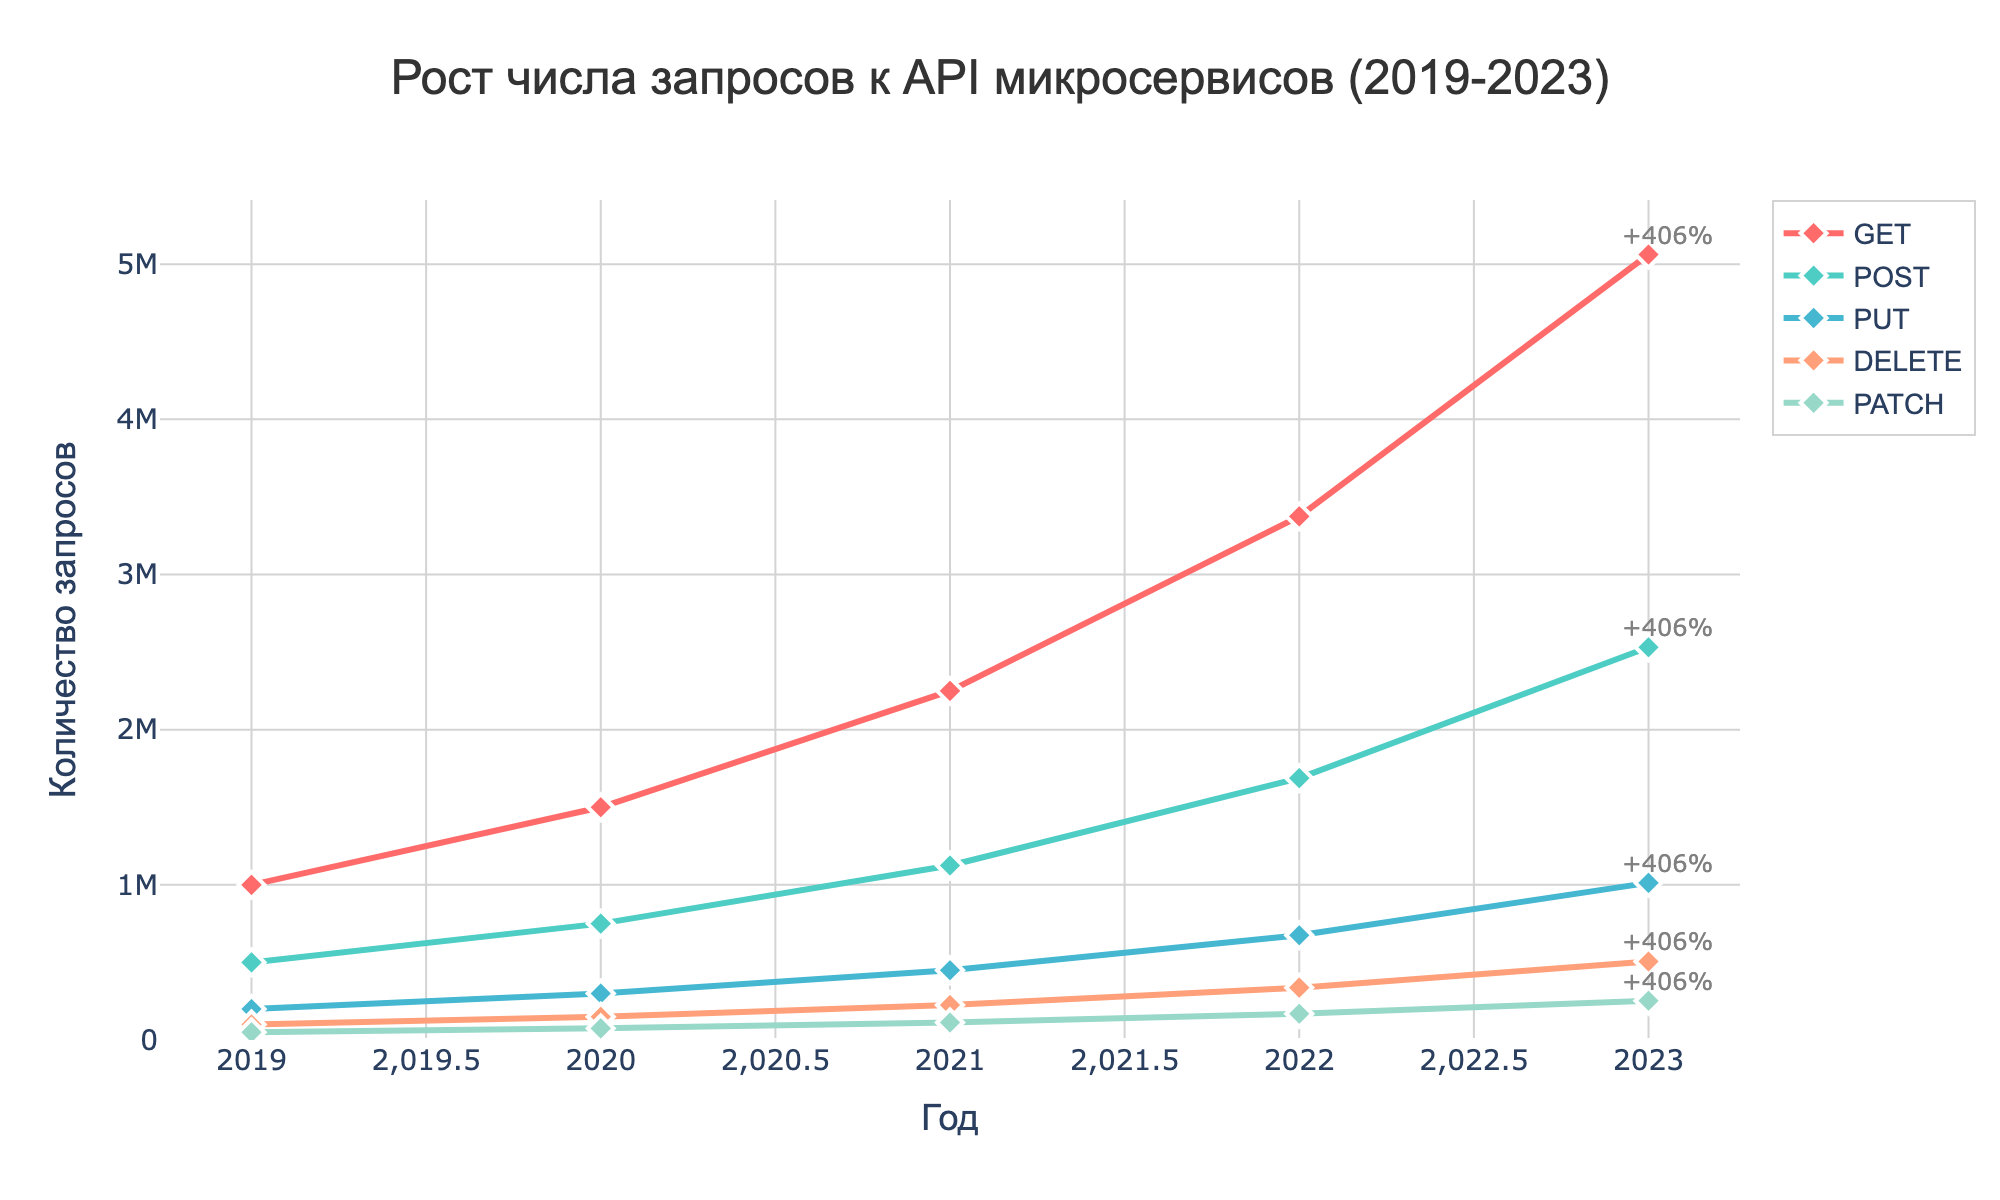what is the total number of GET requests in 2023? Check the figure and find the data point representing GET requests in 2023. The total number is depicted directly on the chart.
Answer: 5062500 How does the number of POST requests in 2019 compare to those in 2023? Look at the chart for POST requests in 2019 and 2023 and compare the two values.
Answer: The number in 2023 is higher What is the percentage growth in DELETE requests from 2019 to 2023? From the chart, note the number of DELETE requests in 2019 and 2023. Calculate the growth percentage: ((506250 - 100000) / 100000) * 100.
Answer: 406% Which request type has the least number of requests in 2020? Examine the chart and compare the number of requests for each type in 2020. The one with the smallest value is the answer.
Answer: PATCH What is the combined number of PUT and DELETE requests in 2022? From the chart, find the number of PUT and DELETE requests in 2022 and add them together. PUT: 675000, DELETE: 337500. 675000 + 337500 = 1012500
Answer: 1012500 How much did the number of GET requests increase from 2021 to 2022? Look at the number of GET requests in 2021 and 2022 from the chart, then subtract the value of 2021 from that of 2022. 3375000 - 2250000 = 1125000
Answer: 1125000 Which year saw the highest percentage increase in PATCH requests compared to the previous year? Calculate the yearly increase percentages for PATCH requests and identify the year with the highest percentage increase.
Answer: 2023 By how much did the number of POST and PUT requests increase from 2021 to 2023? Find POST and PUT requests in 2021 and 2023 from the chart, then subtract the 2021 values from those of 2023 for each type. POST: 2531250 - 1125000 = 1406250, PUT: 1012500 - 450000 = 562500
Answer: POST: 1406250, PUT: 562500 What is the average number of DELETE requests over the five years? Add the number of DELETE requests for all years and divide by 5. (100000 + 150000 + 225000 + 337500 + 506250) / 5 = 1317500 / 5
Answer: 263500 